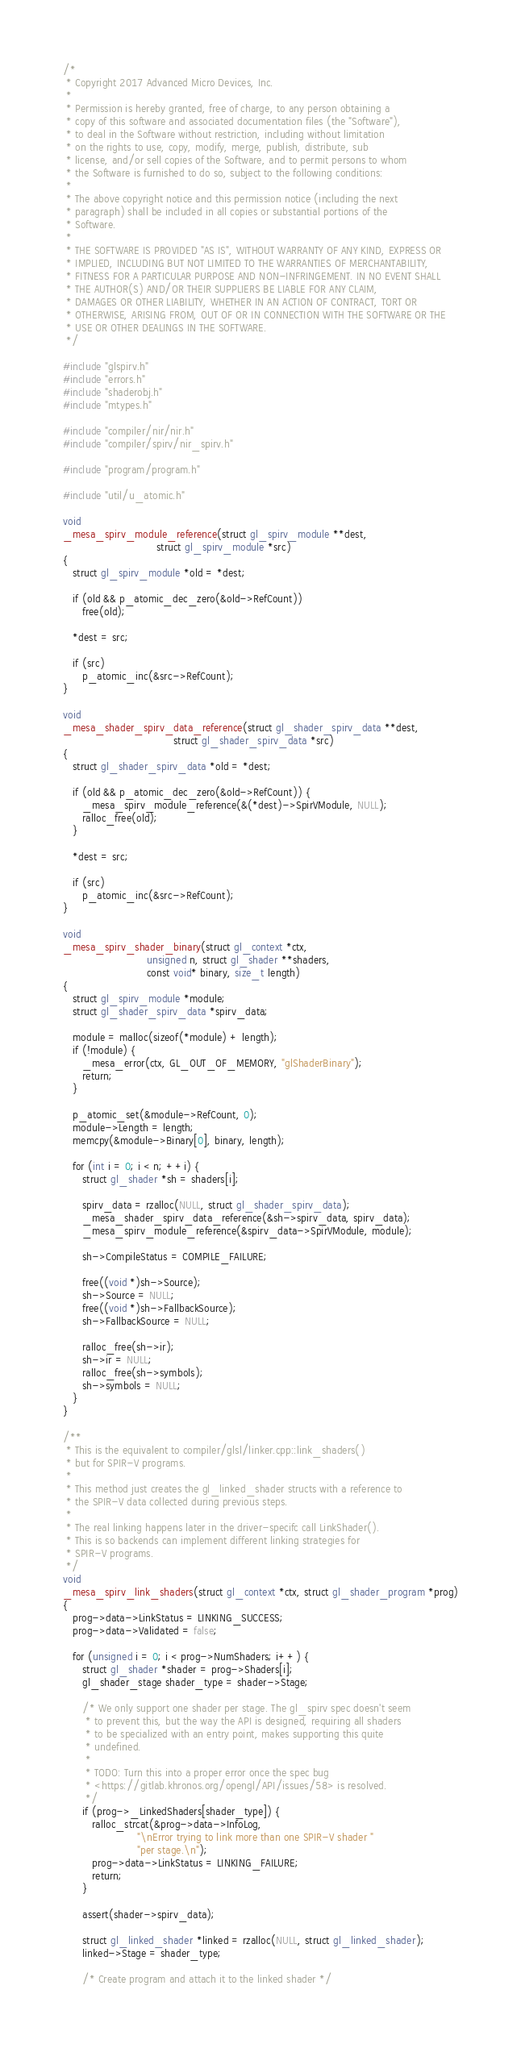Convert code to text. <code><loc_0><loc_0><loc_500><loc_500><_C_>/*
 * Copyright 2017 Advanced Micro Devices, Inc.
 *
 * Permission is hereby granted, free of charge, to any person obtaining a
 * copy of this software and associated documentation files (the "Software"),
 * to deal in the Software without restriction, including without limitation
 * on the rights to use, copy, modify, merge, publish, distribute, sub
 * license, and/or sell copies of the Software, and to permit persons to whom
 * the Software is furnished to do so, subject to the following conditions:
 *
 * The above copyright notice and this permission notice (including the next
 * paragraph) shall be included in all copies or substantial portions of the
 * Software.
 *
 * THE SOFTWARE IS PROVIDED "AS IS", WITHOUT WARRANTY OF ANY KIND, EXPRESS OR
 * IMPLIED, INCLUDING BUT NOT LIMITED TO THE WARRANTIES OF MERCHANTABILITY,
 * FITNESS FOR A PARTICULAR PURPOSE AND NON-INFRINGEMENT. IN NO EVENT SHALL
 * THE AUTHOR(S) AND/OR THEIR SUPPLIERS BE LIABLE FOR ANY CLAIM,
 * DAMAGES OR OTHER LIABILITY, WHETHER IN AN ACTION OF CONTRACT, TORT OR
 * OTHERWISE, ARISING FROM, OUT OF OR IN CONNECTION WITH THE SOFTWARE OR THE
 * USE OR OTHER DEALINGS IN THE SOFTWARE.
 */

#include "glspirv.h"
#include "errors.h"
#include "shaderobj.h"
#include "mtypes.h"

#include "compiler/nir/nir.h"
#include "compiler/spirv/nir_spirv.h"

#include "program/program.h"

#include "util/u_atomic.h"

void
_mesa_spirv_module_reference(struct gl_spirv_module **dest,
                             struct gl_spirv_module *src)
{
   struct gl_spirv_module *old = *dest;

   if (old && p_atomic_dec_zero(&old->RefCount))
      free(old);

   *dest = src;

   if (src)
      p_atomic_inc(&src->RefCount);
}

void
_mesa_shader_spirv_data_reference(struct gl_shader_spirv_data **dest,
                                  struct gl_shader_spirv_data *src)
{
   struct gl_shader_spirv_data *old = *dest;

   if (old && p_atomic_dec_zero(&old->RefCount)) {
      _mesa_spirv_module_reference(&(*dest)->SpirVModule, NULL);
      ralloc_free(old);
   }

   *dest = src;

   if (src)
      p_atomic_inc(&src->RefCount);
}

void
_mesa_spirv_shader_binary(struct gl_context *ctx,
                          unsigned n, struct gl_shader **shaders,
                          const void* binary, size_t length)
{
   struct gl_spirv_module *module;
   struct gl_shader_spirv_data *spirv_data;

   module = malloc(sizeof(*module) + length);
   if (!module) {
      _mesa_error(ctx, GL_OUT_OF_MEMORY, "glShaderBinary");
      return;
   }

   p_atomic_set(&module->RefCount, 0);
   module->Length = length;
   memcpy(&module->Binary[0], binary, length);

   for (int i = 0; i < n; ++i) {
      struct gl_shader *sh = shaders[i];

      spirv_data = rzalloc(NULL, struct gl_shader_spirv_data);
      _mesa_shader_spirv_data_reference(&sh->spirv_data, spirv_data);
      _mesa_spirv_module_reference(&spirv_data->SpirVModule, module);

      sh->CompileStatus = COMPILE_FAILURE;

      free((void *)sh->Source);
      sh->Source = NULL;
      free((void *)sh->FallbackSource);
      sh->FallbackSource = NULL;

      ralloc_free(sh->ir);
      sh->ir = NULL;
      ralloc_free(sh->symbols);
      sh->symbols = NULL;
   }
}

/**
 * This is the equivalent to compiler/glsl/linker.cpp::link_shaders()
 * but for SPIR-V programs.
 *
 * This method just creates the gl_linked_shader structs with a reference to
 * the SPIR-V data collected during previous steps.
 *
 * The real linking happens later in the driver-specifc call LinkShader().
 * This is so backends can implement different linking strategies for
 * SPIR-V programs.
 */
void
_mesa_spirv_link_shaders(struct gl_context *ctx, struct gl_shader_program *prog)
{
   prog->data->LinkStatus = LINKING_SUCCESS;
   prog->data->Validated = false;

   for (unsigned i = 0; i < prog->NumShaders; i++) {
      struct gl_shader *shader = prog->Shaders[i];
      gl_shader_stage shader_type = shader->Stage;

      /* We only support one shader per stage. The gl_spirv spec doesn't seem
       * to prevent this, but the way the API is designed, requiring all shaders
       * to be specialized with an entry point, makes supporting this quite
       * undefined.
       *
       * TODO: Turn this into a proper error once the spec bug
       * <https://gitlab.khronos.org/opengl/API/issues/58> is resolved.
       */
      if (prog->_LinkedShaders[shader_type]) {
         ralloc_strcat(&prog->data->InfoLog,
                       "\nError trying to link more than one SPIR-V shader "
                       "per stage.\n");
         prog->data->LinkStatus = LINKING_FAILURE;
         return;
      }

      assert(shader->spirv_data);

      struct gl_linked_shader *linked = rzalloc(NULL, struct gl_linked_shader);
      linked->Stage = shader_type;

      /* Create program and attach it to the linked shader */</code> 